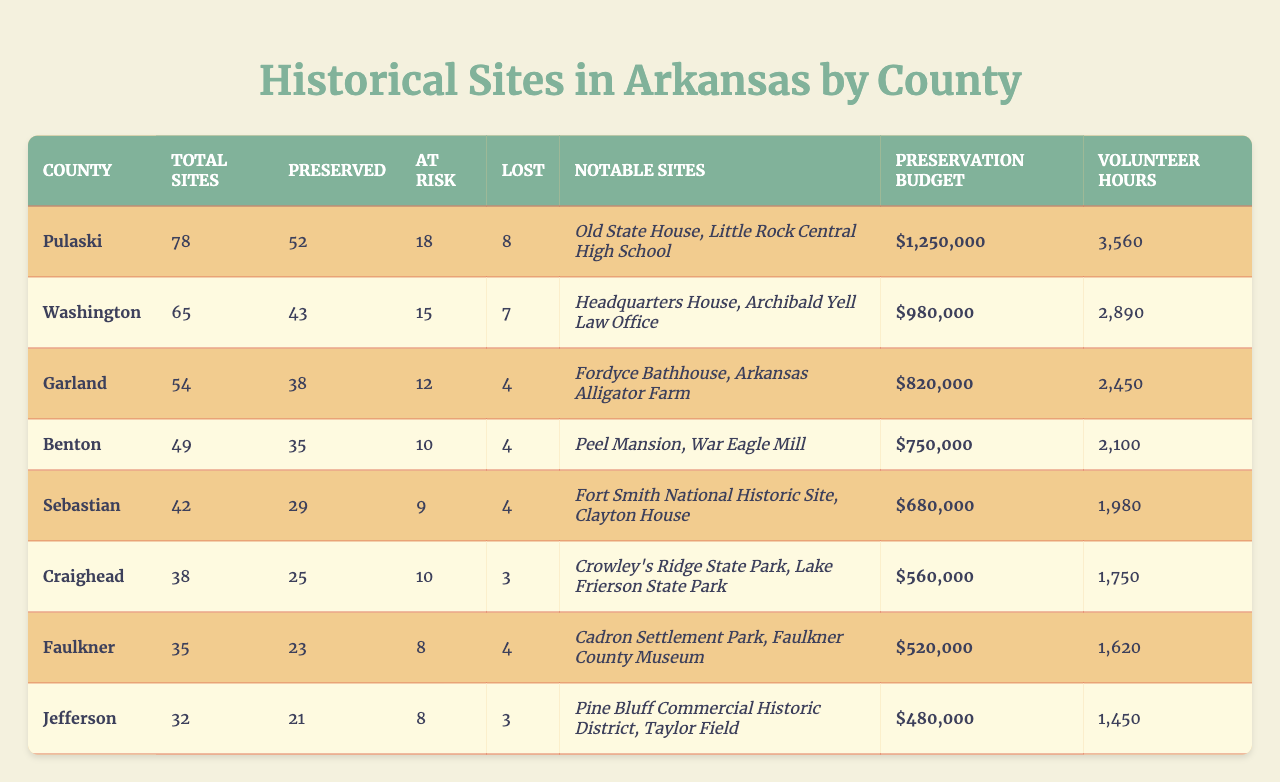What is the total number of historical sites in Pulaski County? The table shows that Pulaski County has a total of 78 historical sites listed.
Answer: 78 How many historical sites in Washington County are at risk? According to the table, Washington County has 15 historical sites that are classified as at risk.
Answer: 15 Which county has the highest preservation budget? By comparing the preservation budgets listed, Pulaski County has the highest at $1,250,000.
Answer: Pulaski County What is the total number of lost sites across all counties? Adding the lost sites from each county: 8 (Pulaski) + 7 (Washington) + 4 (Garland) + 4 (Benton) + 4 (Sebastian) + 3 (Craighead) + 4 (Faulkner) + 3 (Jefferson) = 37 total lost sites.
Answer: 37 Is there any county that does not have any lost sites? The table shows that Craighead County has 3 lost sites, while other counties have at least 4, meaning there is no county without lost sites.
Answer: No What percentage of historical sites in Garland County are preserved? Garland County has 54 total sites, with 38 preserved. Calculating the percentage: (38/54) * 100 = 70.37%.
Answer: 70.37% Which notable site in Sebastian County is mentioned first? The table lists "Fort Smith National Historic Site" as the first notable site in Sebastian County.
Answer: Fort Smith National Historic Site What is the average number of preserved sites in the counties listed? The total preserved sites across all counties are 52 (Pulaski) + 43 (Washington) + 38 (Garland) + 35 (Benton) + 29 (Sebastian) + 25 (Craighead) + 23 (Faulkner) + 21 (Jefferson) = 296. Since there are 8 counties, the average is 296/8 = 37.
Answer: 37 Which county has the least number of volunteer hours? By examining the volunteer hours for each county, Jefferson County has the least with 1,450 hours.
Answer: Jefferson County How many more preserved sites does Pulaski County have compared to Benton County? Pulaski County has 52 preserved sites and Benton County has 35. The difference is 52 - 35 = 17.
Answer: 17 